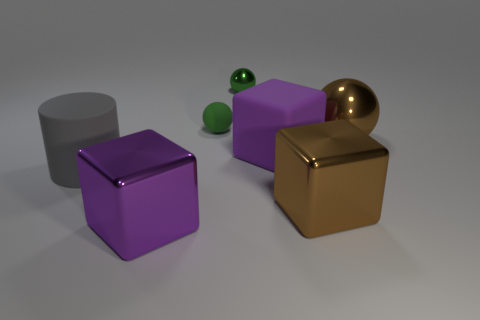Subtract all large matte cubes. How many cubes are left? 2 Subtract all brown spheres. How many spheres are left? 2 Subtract 1 spheres. How many spheres are left? 2 Subtract all yellow balls. Subtract all red cylinders. How many balls are left? 3 Add 3 small green metallic balls. How many objects exist? 10 Subtract all cyan cylinders. How many green spheres are left? 2 Subtract all large brown cubes. Subtract all big brown shiny spheres. How many objects are left? 5 Add 7 metallic blocks. How many metallic blocks are left? 9 Add 1 large green matte balls. How many large green matte balls exist? 1 Subtract 0 gray balls. How many objects are left? 7 